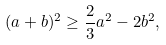Convert formula to latex. <formula><loc_0><loc_0><loc_500><loc_500>( a + b ) ^ { 2 } \geq \frac { 2 } { 3 } a ^ { 2 } - 2 b ^ { 2 } ,</formula> 